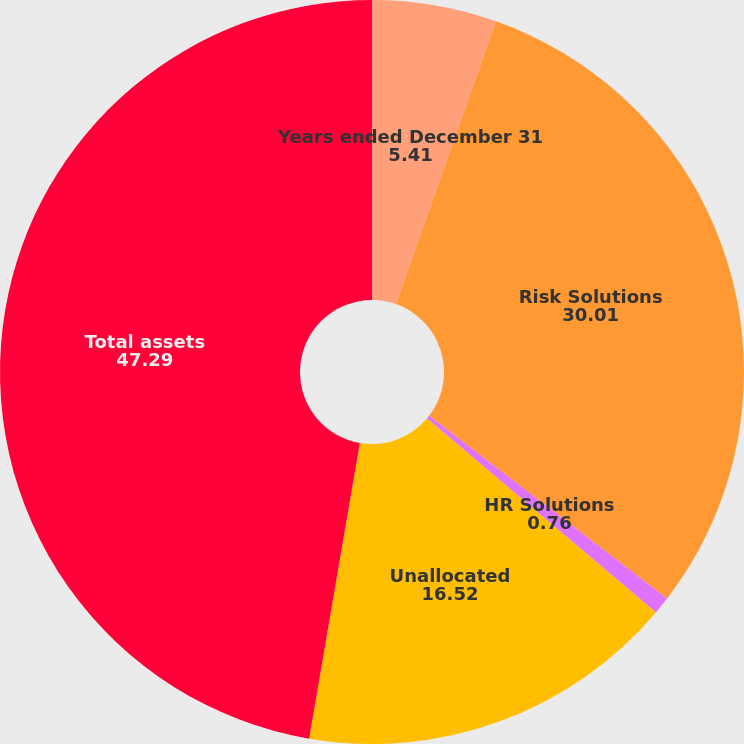<chart> <loc_0><loc_0><loc_500><loc_500><pie_chart><fcel>Years ended December 31<fcel>Risk Solutions<fcel>HR Solutions<fcel>Unallocated<fcel>Total assets<nl><fcel>5.41%<fcel>30.01%<fcel>0.76%<fcel>16.52%<fcel>47.29%<nl></chart> 